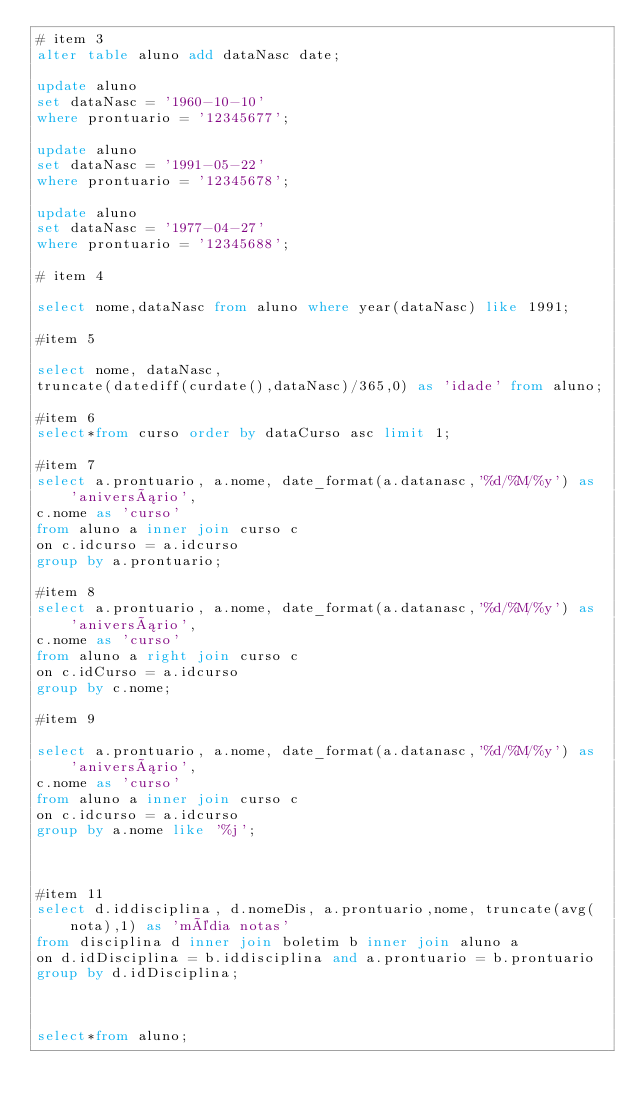Convert code to text. <code><loc_0><loc_0><loc_500><loc_500><_SQL_># item 3
alter table aluno add dataNasc date;

update aluno
set dataNasc = '1960-10-10'
where prontuario = '12345677';

update aluno
set dataNasc = '1991-05-22'
where prontuario = '12345678';

update aluno
set dataNasc = '1977-04-27'
where prontuario = '12345688';

# item 4

select nome,dataNasc from aluno where year(dataNasc) like 1991;

#item 5

select nome, dataNasc,
truncate(datediff(curdate(),dataNasc)/365,0) as 'idade' from aluno;

#item 6
select*from curso order by dataCurso asc limit 1;

#item 7
select a.prontuario, a.nome, date_format(a.datanasc,'%d/%M/%y') as 'aniversário',
c.nome as 'curso'
from aluno a inner join curso c
on c.idcurso = a.idcurso
group by a.prontuario;

#item 8
select a.prontuario, a.nome, date_format(a.datanasc,'%d/%M/%y') as 'aniversário',
c.nome as 'curso'
from aluno a right join curso c
on c.idCurso = a.idcurso
group by c.nome;

#item 9

select a.prontuario, a.nome, date_format(a.datanasc,'%d/%M/%y') as 'aniversário',
c.nome as 'curso'
from aluno a inner join curso c
on c.idcurso = a.idcurso
group by a.nome like '%j';



#item 11
select d.iddisciplina, d.nomeDis, a.prontuario,nome, truncate(avg(nota),1) as 'média notas'
from disciplina d inner join boletim b inner join aluno a
on d.idDisciplina = b.iddisciplina and a.prontuario = b.prontuario
group by d.idDisciplina;



select*from aluno;</code> 